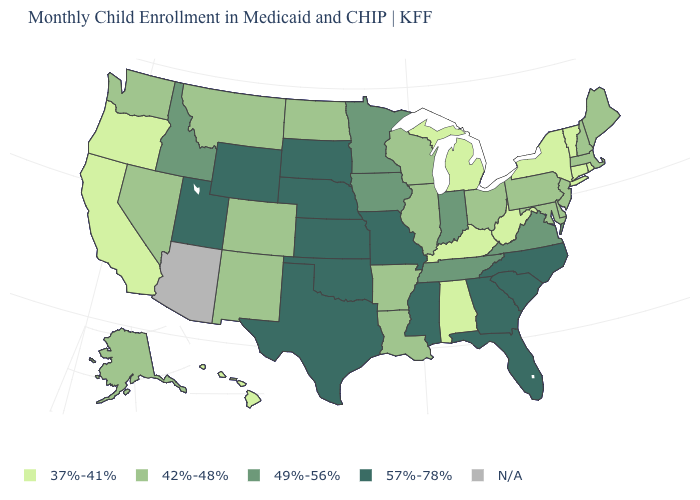Does Hawaii have the lowest value in the West?
Quick response, please. Yes. Is the legend a continuous bar?
Answer briefly. No. What is the value of Virginia?
Concise answer only. 49%-56%. What is the value of New Hampshire?
Write a very short answer. 42%-48%. Among the states that border Tennessee , which have the lowest value?
Give a very brief answer. Alabama, Kentucky. What is the value of Iowa?
Keep it brief. 49%-56%. Name the states that have a value in the range 42%-48%?
Give a very brief answer. Alaska, Arkansas, Colorado, Delaware, Illinois, Louisiana, Maine, Maryland, Massachusetts, Montana, Nevada, New Hampshire, New Jersey, New Mexico, North Dakota, Ohio, Pennsylvania, Washington, Wisconsin. Is the legend a continuous bar?
Concise answer only. No. Does the map have missing data?
Concise answer only. Yes. Does Rhode Island have the lowest value in the USA?
Quick response, please. Yes. Does New York have the highest value in the Northeast?
Give a very brief answer. No. What is the value of Alaska?
Answer briefly. 42%-48%. What is the value of Wisconsin?
Write a very short answer. 42%-48%. What is the lowest value in the USA?
Quick response, please. 37%-41%. 